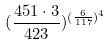Convert formula to latex. <formula><loc_0><loc_0><loc_500><loc_500>( \frac { 4 5 1 \cdot 3 } { 4 2 3 } ) ^ { ( \frac { 6 } { 1 1 7 } ) ^ { 4 } }</formula> 